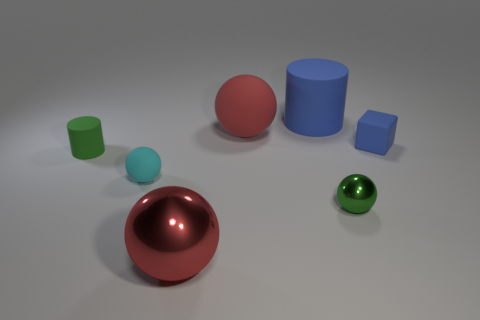What number of rubber things are both left of the big shiny thing and behind the tiny blue block?
Make the answer very short. 0. There is another thing that is the same color as the big metal object; what is its shape?
Offer a very short reply. Sphere. Is the material of the blue cube the same as the big blue cylinder?
Offer a very short reply. Yes. What is the shape of the tiny green thing to the left of the red shiny sphere in front of the sphere left of the big red metallic sphere?
Ensure brevity in your answer.  Cylinder. Is the number of large matte balls in front of the red metal sphere less than the number of big blue things that are to the right of the cyan object?
Provide a succinct answer. Yes. What shape is the red object that is behind the red ball that is in front of the small block?
Make the answer very short. Sphere. Are there any other things of the same color as the tiny rubber sphere?
Give a very brief answer. No. Is the small block the same color as the big cylinder?
Provide a short and direct response. Yes. How many red things are small things or small rubber things?
Your answer should be compact. 0. Are there fewer cylinders behind the green cylinder than large green cubes?
Make the answer very short. No. 